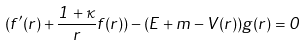Convert formula to latex. <formula><loc_0><loc_0><loc_500><loc_500>( f ^ { \prime } ( r ) + \frac { 1 + \kappa } { r } f ( r ) ) - ( E + m - V ( r ) ) g ( r ) = 0</formula> 